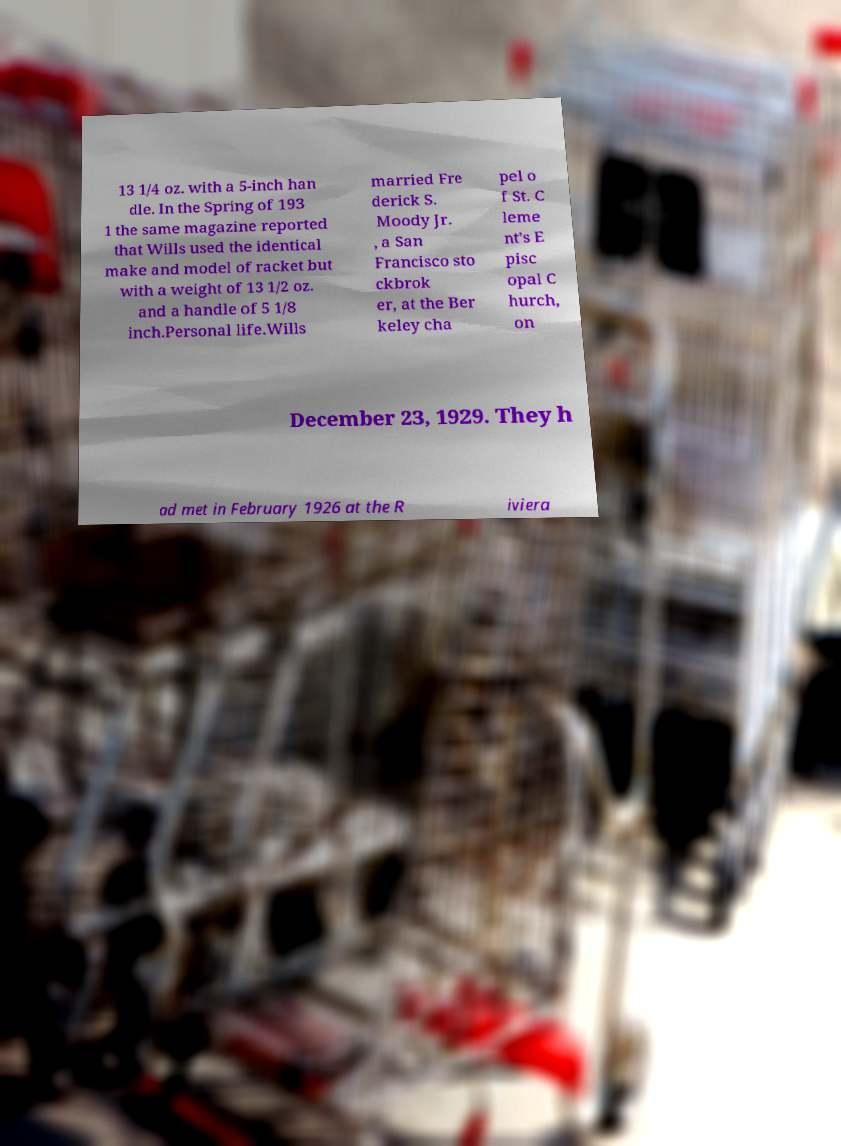For documentation purposes, I need the text within this image transcribed. Could you provide that? 13 1/4 oz. with a 5-inch han dle. In the Spring of 193 1 the same magazine reported that Wills used the identical make and model of racket but with a weight of 13 1/2 oz. and a handle of 5 1/8 inch.Personal life.Wills married Fre derick S. Moody Jr. , a San Francisco sto ckbrok er, at the Ber keley cha pel o f St. C leme nt's E pisc opal C hurch, on December 23, 1929. They h ad met in February 1926 at the R iviera 